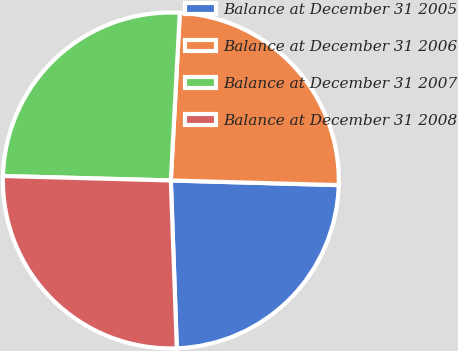Convert chart. <chart><loc_0><loc_0><loc_500><loc_500><pie_chart><fcel>Balance at December 31 2005<fcel>Balance at December 31 2006<fcel>Balance at December 31 2007<fcel>Balance at December 31 2008<nl><fcel>23.99%<fcel>24.59%<fcel>25.43%<fcel>25.99%<nl></chart> 